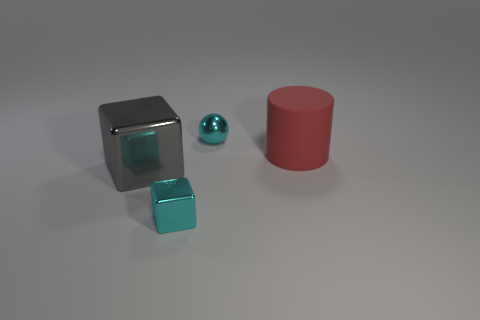Subtract 1 cylinders. How many cylinders are left? 0 Subtract all gray cubes. How many cubes are left? 1 Add 1 large objects. How many objects exist? 5 Subtract all cyan cylinders. How many cyan blocks are left? 1 Subtract all balls. How many objects are left? 3 Subtract all green cubes. Subtract all blue spheres. How many cubes are left? 2 Subtract all metallic spheres. Subtract all balls. How many objects are left? 2 Add 1 small things. How many small things are left? 3 Add 4 large metal blocks. How many large metal blocks exist? 5 Subtract 0 blue spheres. How many objects are left? 4 